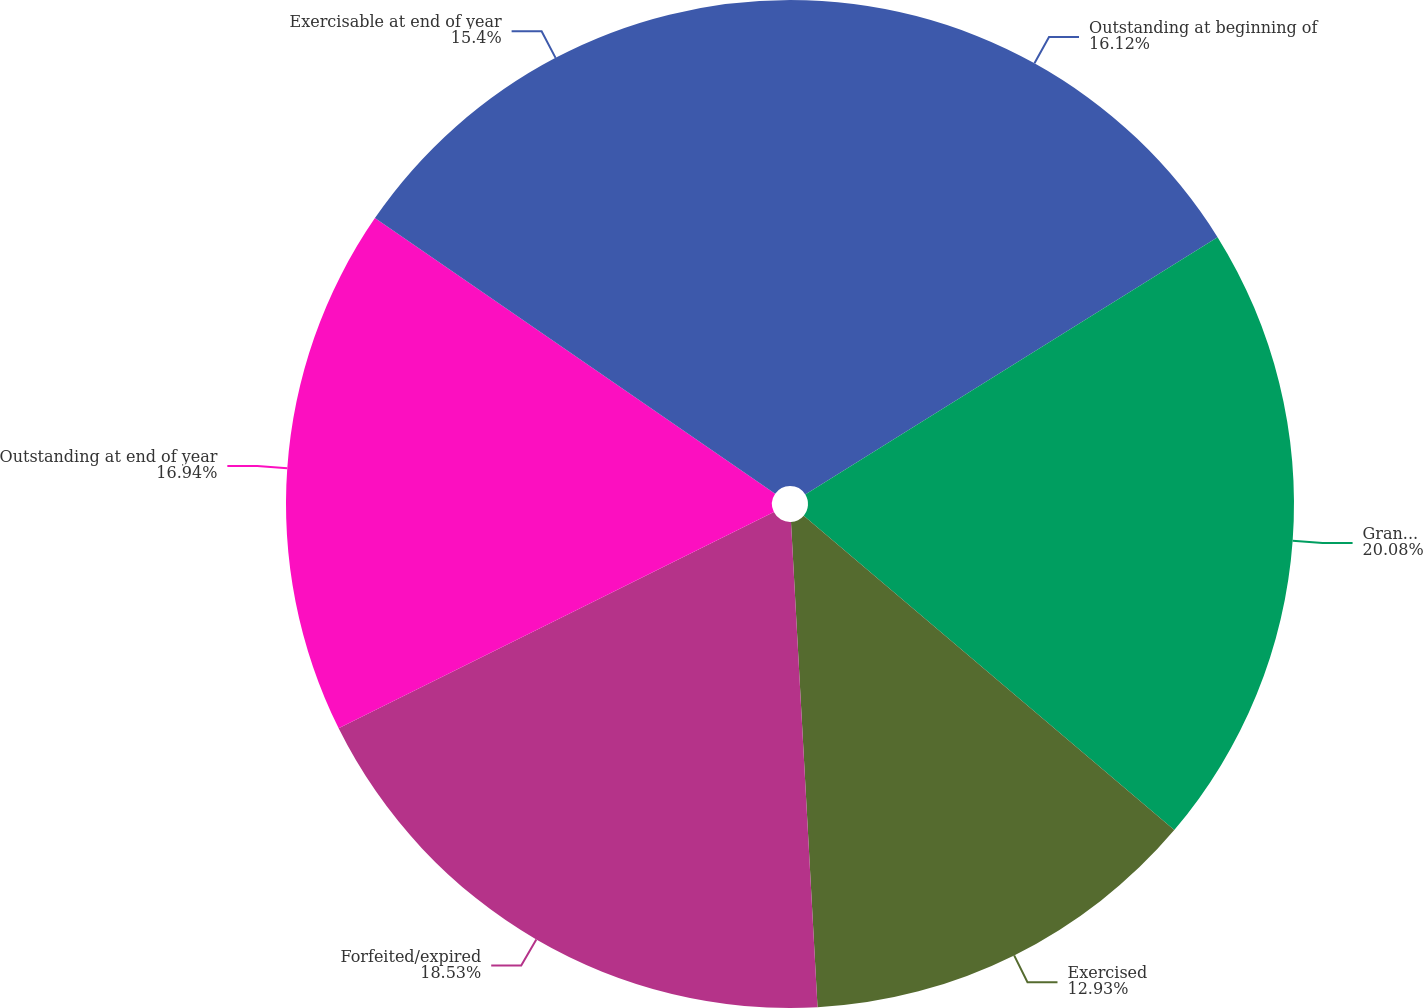Convert chart to OTSL. <chart><loc_0><loc_0><loc_500><loc_500><pie_chart><fcel>Outstanding at beginning of<fcel>Granted<fcel>Exercised<fcel>Forfeited/expired<fcel>Outstanding at end of year<fcel>Exercisable at end of year<nl><fcel>16.12%<fcel>20.08%<fcel>12.93%<fcel>18.53%<fcel>16.94%<fcel>15.4%<nl></chart> 